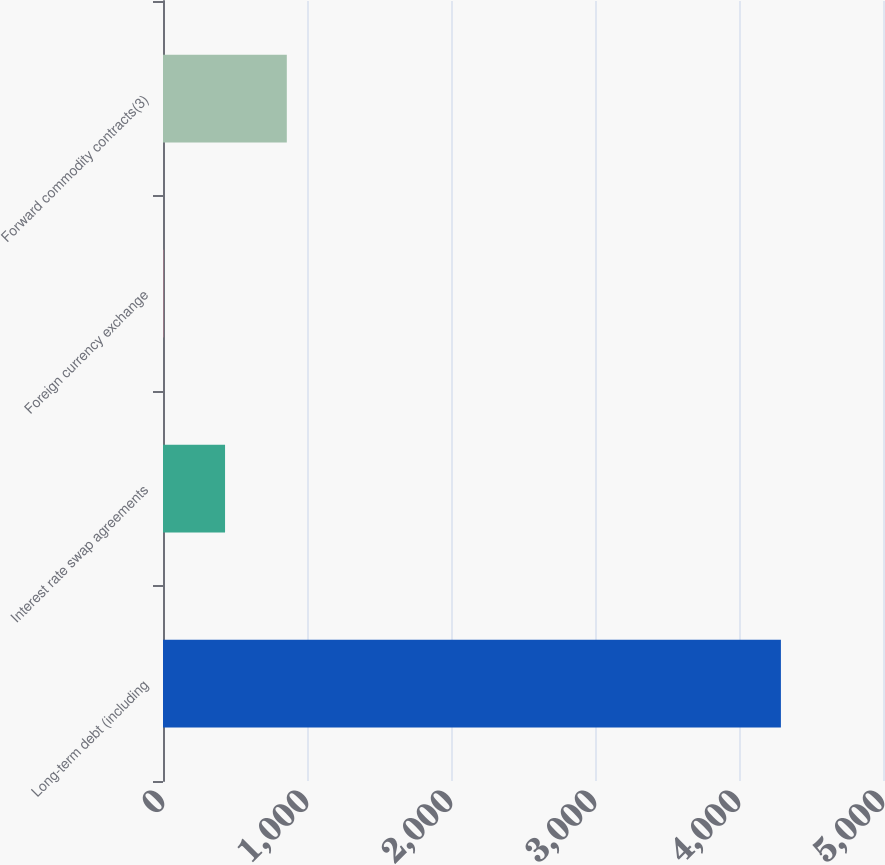Convert chart. <chart><loc_0><loc_0><loc_500><loc_500><bar_chart><fcel>Long-term debt (including<fcel>Interest rate swap agreements<fcel>Foreign currency exchange<fcel>Forward commodity contracts(3)<nl><fcel>4291<fcel>430.9<fcel>2<fcel>859.8<nl></chart> 